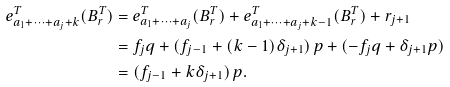<formula> <loc_0><loc_0><loc_500><loc_500>e _ { a _ { 1 } + \cdots + a _ { j } + k } ^ { T } ( B _ { r } ^ { T } ) & = e _ { a _ { 1 } + \cdots + a _ { j } } ^ { T } ( B _ { r } ^ { T } ) + e _ { a _ { 1 } + \cdots + a _ { j } + k - 1 } ^ { T } ( B _ { r } ^ { T } ) + r _ { j + 1 } \\ & = f _ { j } q + ( f _ { j - 1 } + ( k - 1 ) \delta _ { j + 1 } ) \, p + ( - f _ { j } q + \delta _ { j + 1 } p ) \\ & = ( f _ { j - 1 } + k \delta _ { j + 1 } ) \, p .</formula> 